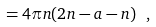Convert formula to latex. <formula><loc_0><loc_0><loc_500><loc_500>= 4 \pi n ( 2 n - a - n ) \ ,</formula> 